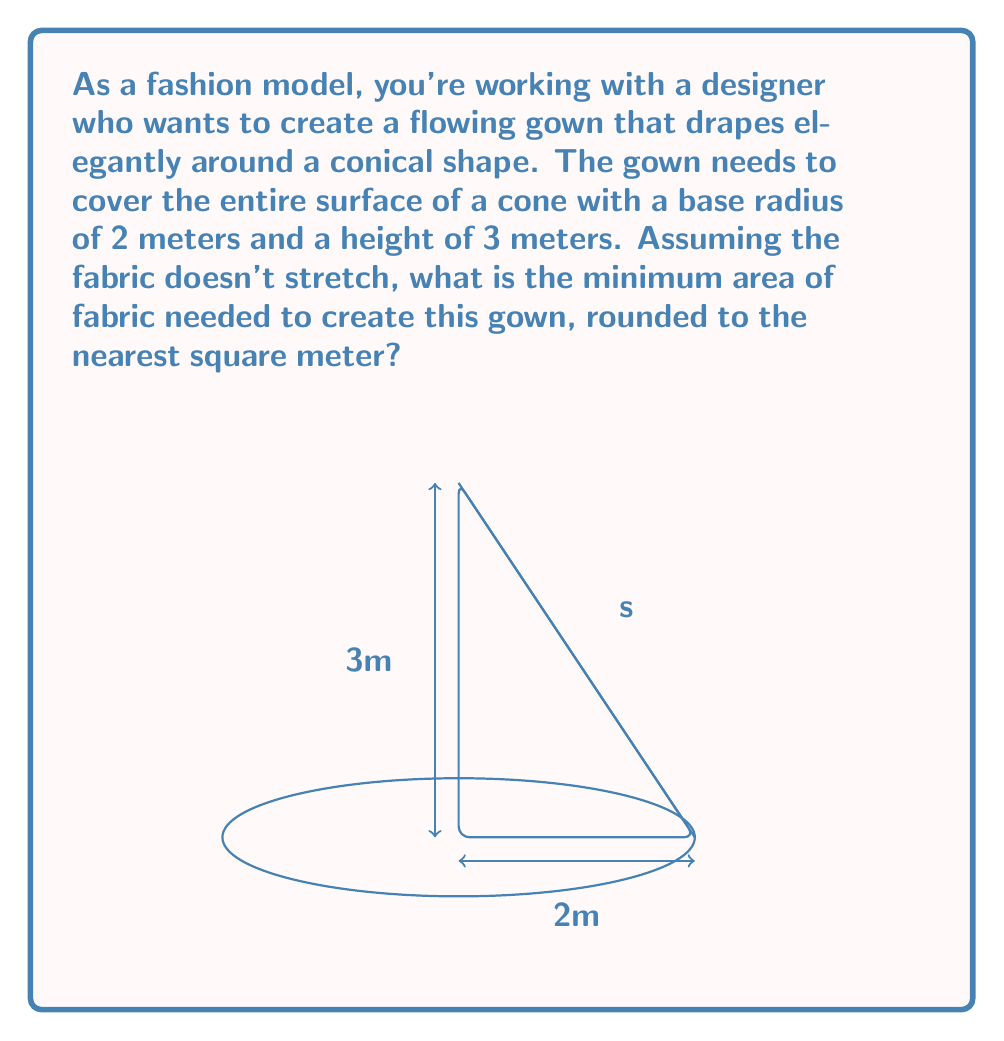Can you answer this question? Let's approach this step-by-step:

1) The surface of the gown will be composed of two parts:
   a) The circular base of the cone
   b) The lateral surface of the cone

2) For the circular base:
   Area = $\pi r^2 = \pi (2)^2 = 4\pi$ m²

3) For the lateral surface, we need to find the slant height (s) of the cone:
   $s = \sqrt{r^2 + h^2} = \sqrt{2^2 + 3^2} = \sqrt{4 + 9} = \sqrt{13}$ m

4) The lateral surface of a cone is a sector of a circle. Its area is given by:
   $A_{lateral} = \pi r s$

   Where $r$ is the radius of the base and $s$ is the slant height.

5) Substituting our values:
   $A_{lateral} = \pi (2) (\sqrt{13}) = 2\pi\sqrt{13}$ m²

6) Total area needed:
   $A_{total} = A_{base} + A_{lateral} = 4\pi + 2\pi\sqrt{13}$ m²

7) Simplifying:
   $A_{total} = \pi(4 + 2\sqrt{13})$ m²

8) Calculating and rounding to the nearest square meter:
   $A_{total} \approx 3.14159 * (4 + 2 * 3.60555) \approx 35.13$ m²
   Rounded to the nearest square meter: 35 m²
Answer: 35 m² 